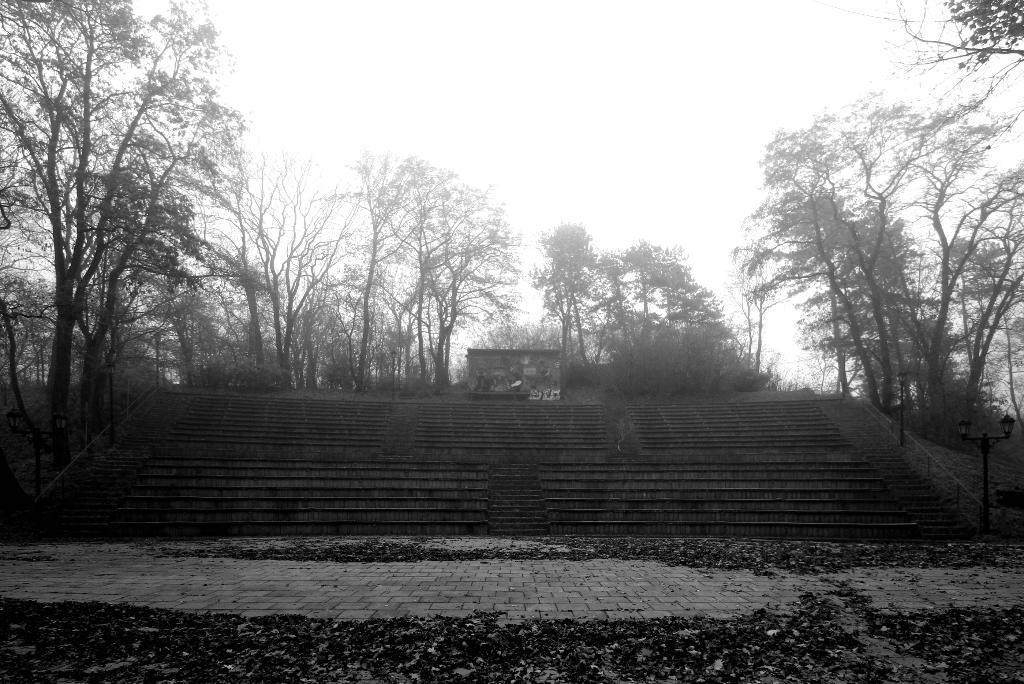Could you give a brief overview of what you see in this image? This is the black and white image and we can see some trees and we can see the stairs in the middle and there are some light poles. We can see some dry leaves on the ground and at the top we can see the sky. 